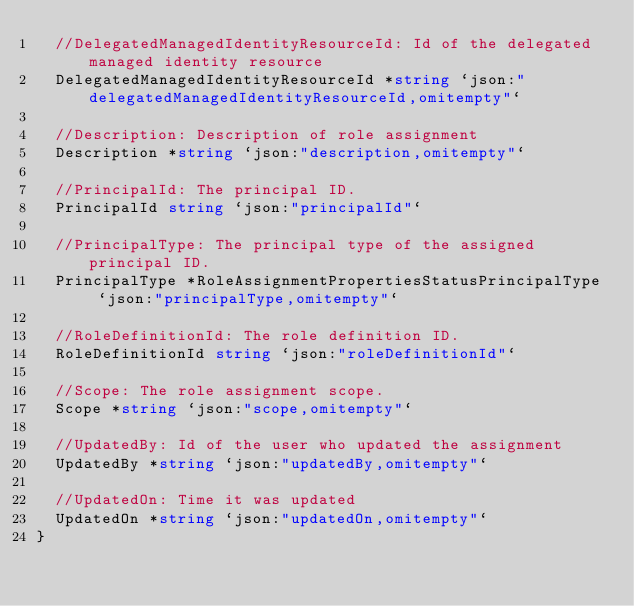<code> <loc_0><loc_0><loc_500><loc_500><_Go_>	//DelegatedManagedIdentityResourceId: Id of the delegated managed identity resource
	DelegatedManagedIdentityResourceId *string `json:"delegatedManagedIdentityResourceId,omitempty"`

	//Description: Description of role assignment
	Description *string `json:"description,omitempty"`

	//PrincipalId: The principal ID.
	PrincipalId string `json:"principalId"`

	//PrincipalType: The principal type of the assigned principal ID.
	PrincipalType *RoleAssignmentPropertiesStatusPrincipalType `json:"principalType,omitempty"`

	//RoleDefinitionId: The role definition ID.
	RoleDefinitionId string `json:"roleDefinitionId"`

	//Scope: The role assignment scope.
	Scope *string `json:"scope,omitempty"`

	//UpdatedBy: Id of the user who updated the assignment
	UpdatedBy *string `json:"updatedBy,omitempty"`

	//UpdatedOn: Time it was updated
	UpdatedOn *string `json:"updatedOn,omitempty"`
}
</code> 